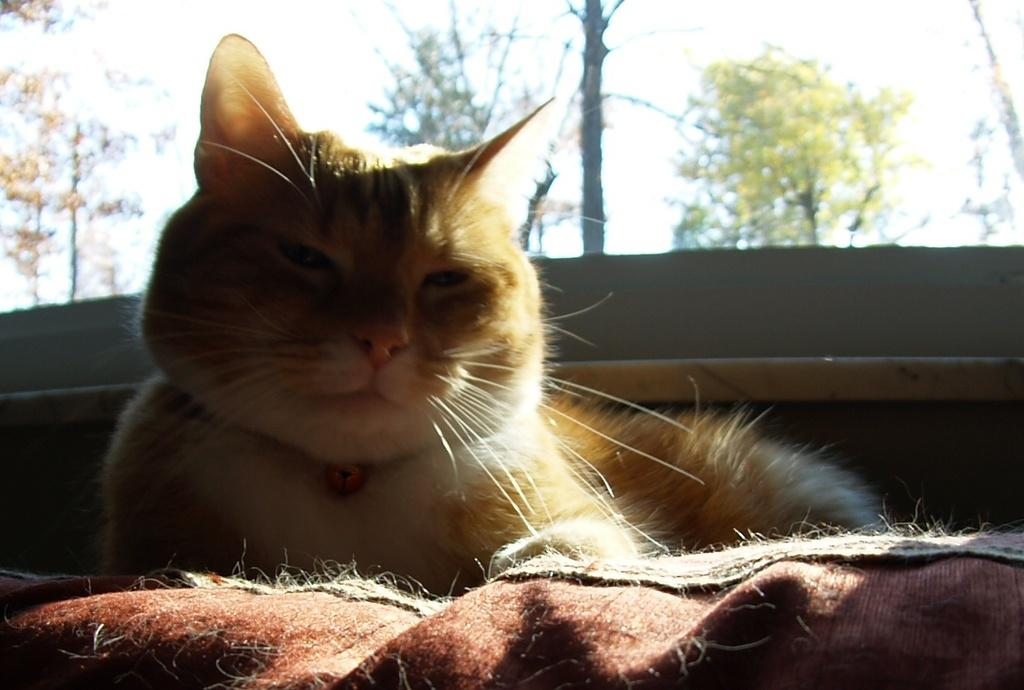What animal is present in the image? There is a cat in the image. What is the cat sitting on? The cat is sitting on a cloth. How would you describe the background of the image? The background of the image is blurred. What type of natural scenery can be seen in the background? There are trees visible in the background. How does the cat's skin react to the quicksand in the image? There is no quicksand present in the image, so the cat's skin does not react to it. 